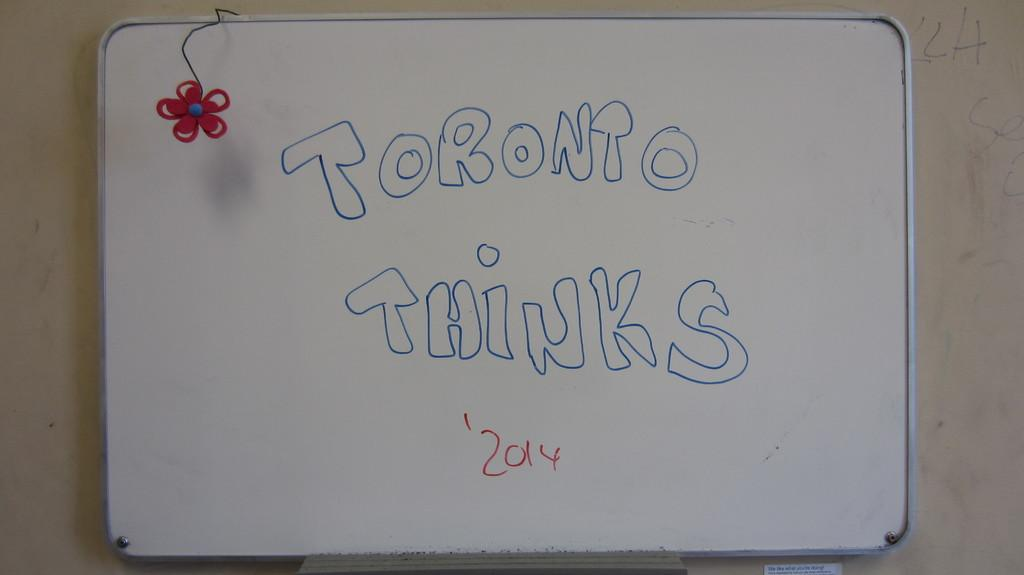Provide a one-sentence caption for the provided image. White board with the words Toronto Thinks in blue on it. 